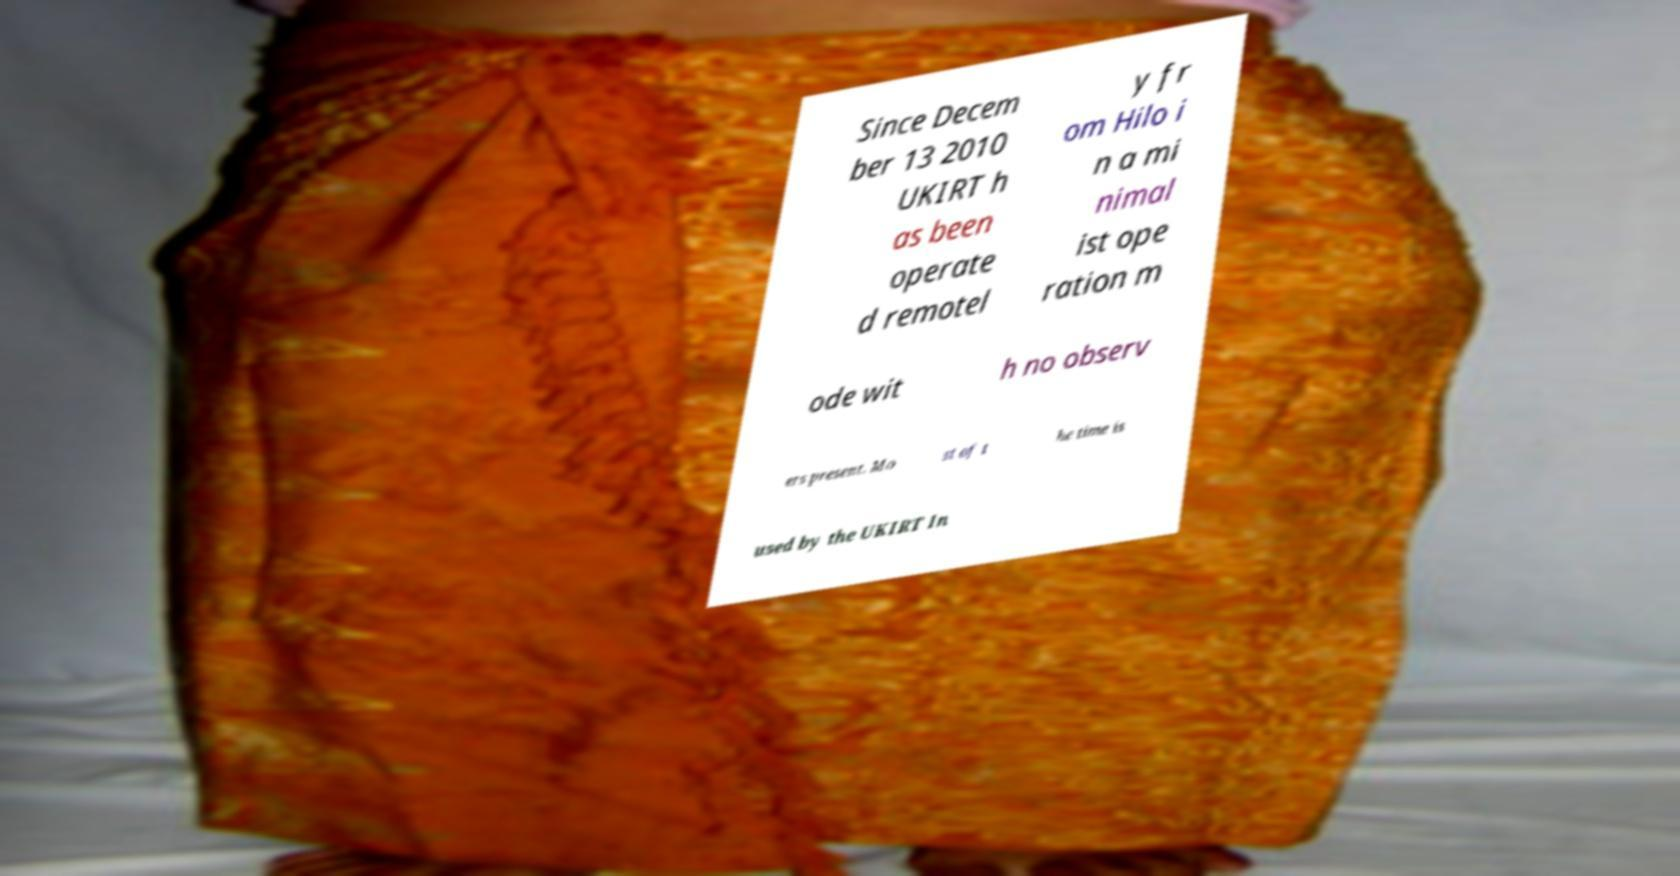Could you extract and type out the text from this image? Since Decem ber 13 2010 UKIRT h as been operate d remotel y fr om Hilo i n a mi nimal ist ope ration m ode wit h no observ ers present. Mo st of t he time is used by the UKIRT In 